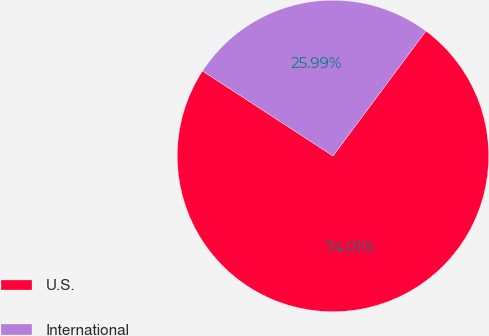Convert chart. <chart><loc_0><loc_0><loc_500><loc_500><pie_chart><fcel>U.S.<fcel>International<nl><fcel>74.01%<fcel>25.99%<nl></chart> 